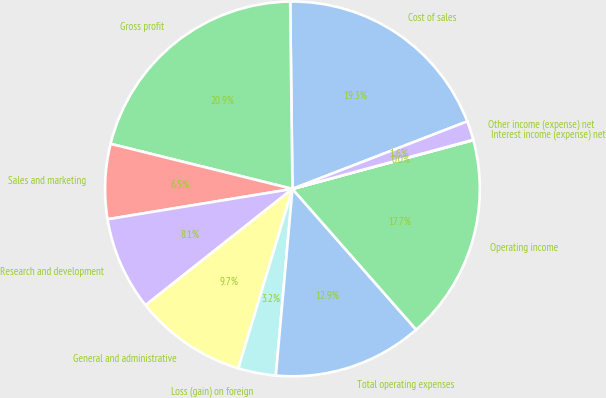Convert chart. <chart><loc_0><loc_0><loc_500><loc_500><pie_chart><fcel>Cost of sales<fcel>Gross profit<fcel>Sales and marketing<fcel>Research and development<fcel>General and administrative<fcel>Loss (gain) on foreign<fcel>Total operating expenses<fcel>Operating income<fcel>Interest income (expense) net<fcel>Other income (expense) net<nl><fcel>19.33%<fcel>20.94%<fcel>6.46%<fcel>8.07%<fcel>9.68%<fcel>3.25%<fcel>12.89%<fcel>17.72%<fcel>0.03%<fcel>1.64%<nl></chart> 